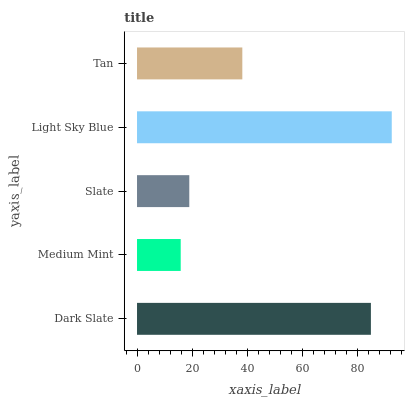Is Medium Mint the minimum?
Answer yes or no. Yes. Is Light Sky Blue the maximum?
Answer yes or no. Yes. Is Slate the minimum?
Answer yes or no. No. Is Slate the maximum?
Answer yes or no. No. Is Slate greater than Medium Mint?
Answer yes or no. Yes. Is Medium Mint less than Slate?
Answer yes or no. Yes. Is Medium Mint greater than Slate?
Answer yes or no. No. Is Slate less than Medium Mint?
Answer yes or no. No. Is Tan the high median?
Answer yes or no. Yes. Is Tan the low median?
Answer yes or no. Yes. Is Slate the high median?
Answer yes or no. No. Is Light Sky Blue the low median?
Answer yes or no. No. 